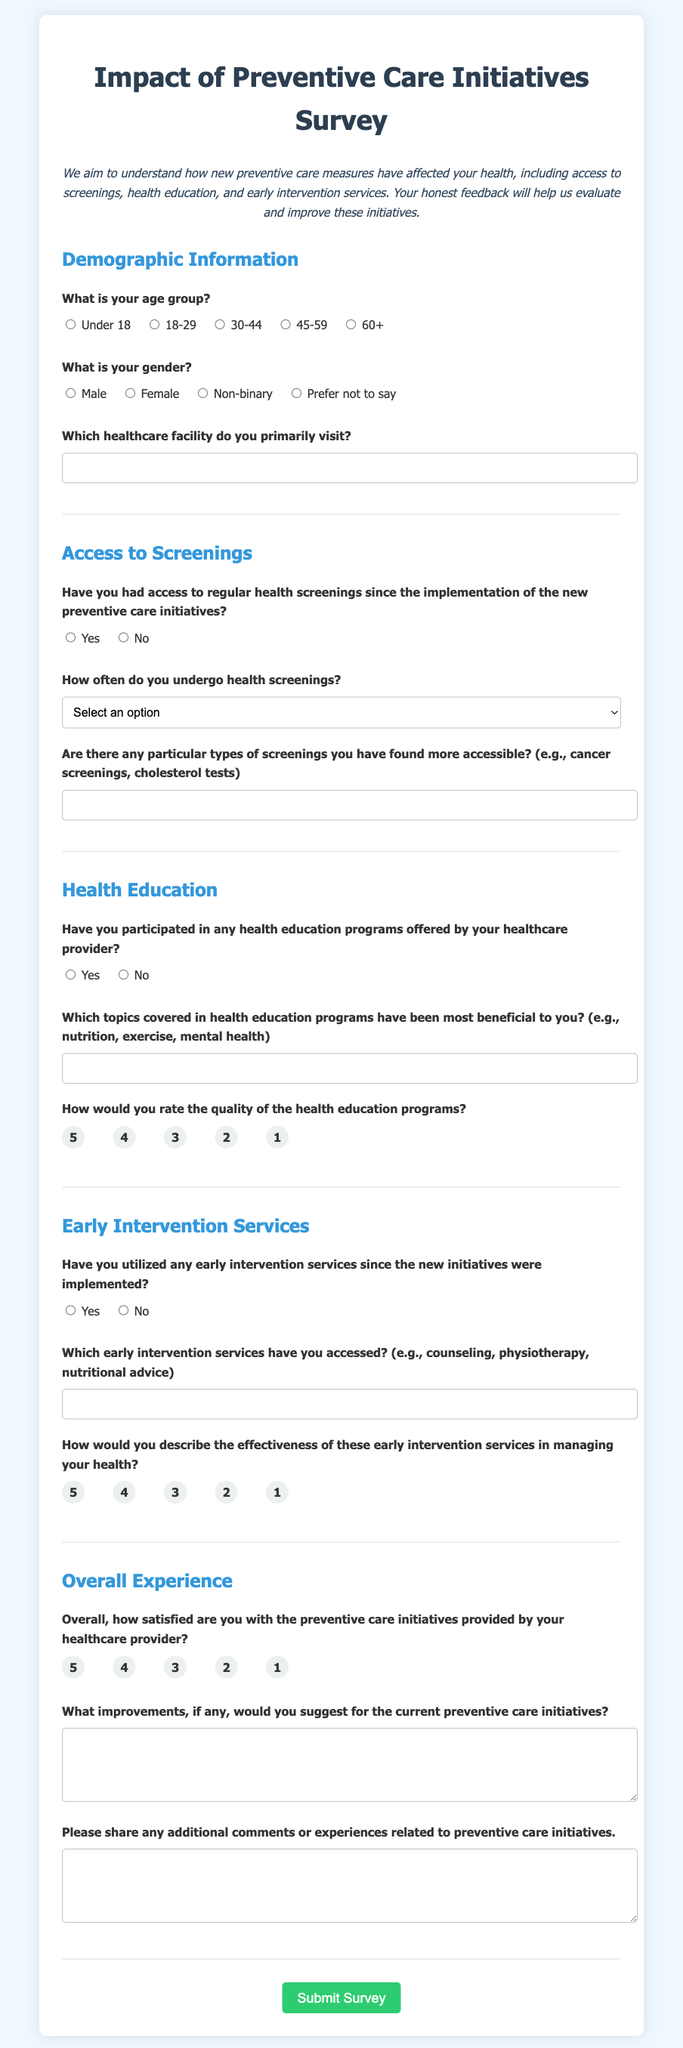What is the title of the survey? The title of the survey is displayed prominently at the top of the document.
Answer: Impact of Preventive Care Initiatives Survey What is one type of information requested about demographic details? The document asks for gender as one of the demographic details.
Answer: Gender How is participant feedback collected in this survey? The survey form includes a button at the end for submitting responses, making it clear feedback is collected electronically.
Answer: Submit Survey How often are participants asked to rate the quality of health education programs? This information is gathered in one of the questions regarding the effectiveness of the programs.
Answer: 1 to 5 scale What age group options are provided in the survey? The survey includes specific options for age groups that participants can select.
Answer: Under 18, 18-29, 30-44, 45-59, 60+ Have the healthcare reforms affected access to regular health screenings according to the survey? The survey includes a specific question about access to health screenings since reforms were implemented.
Answer: Yes/No What kind of feedback is requested regarding early intervention services? The survey seeks detailed input about the services accessed and their effectiveness.
Answer: Accessed services and effectiveness What is suggested for participants to include in the additional comments section? Participants are encouraged to share extra thoughts or experiences related to the initiatives in this section.
Answer: Additional comments or experiences 